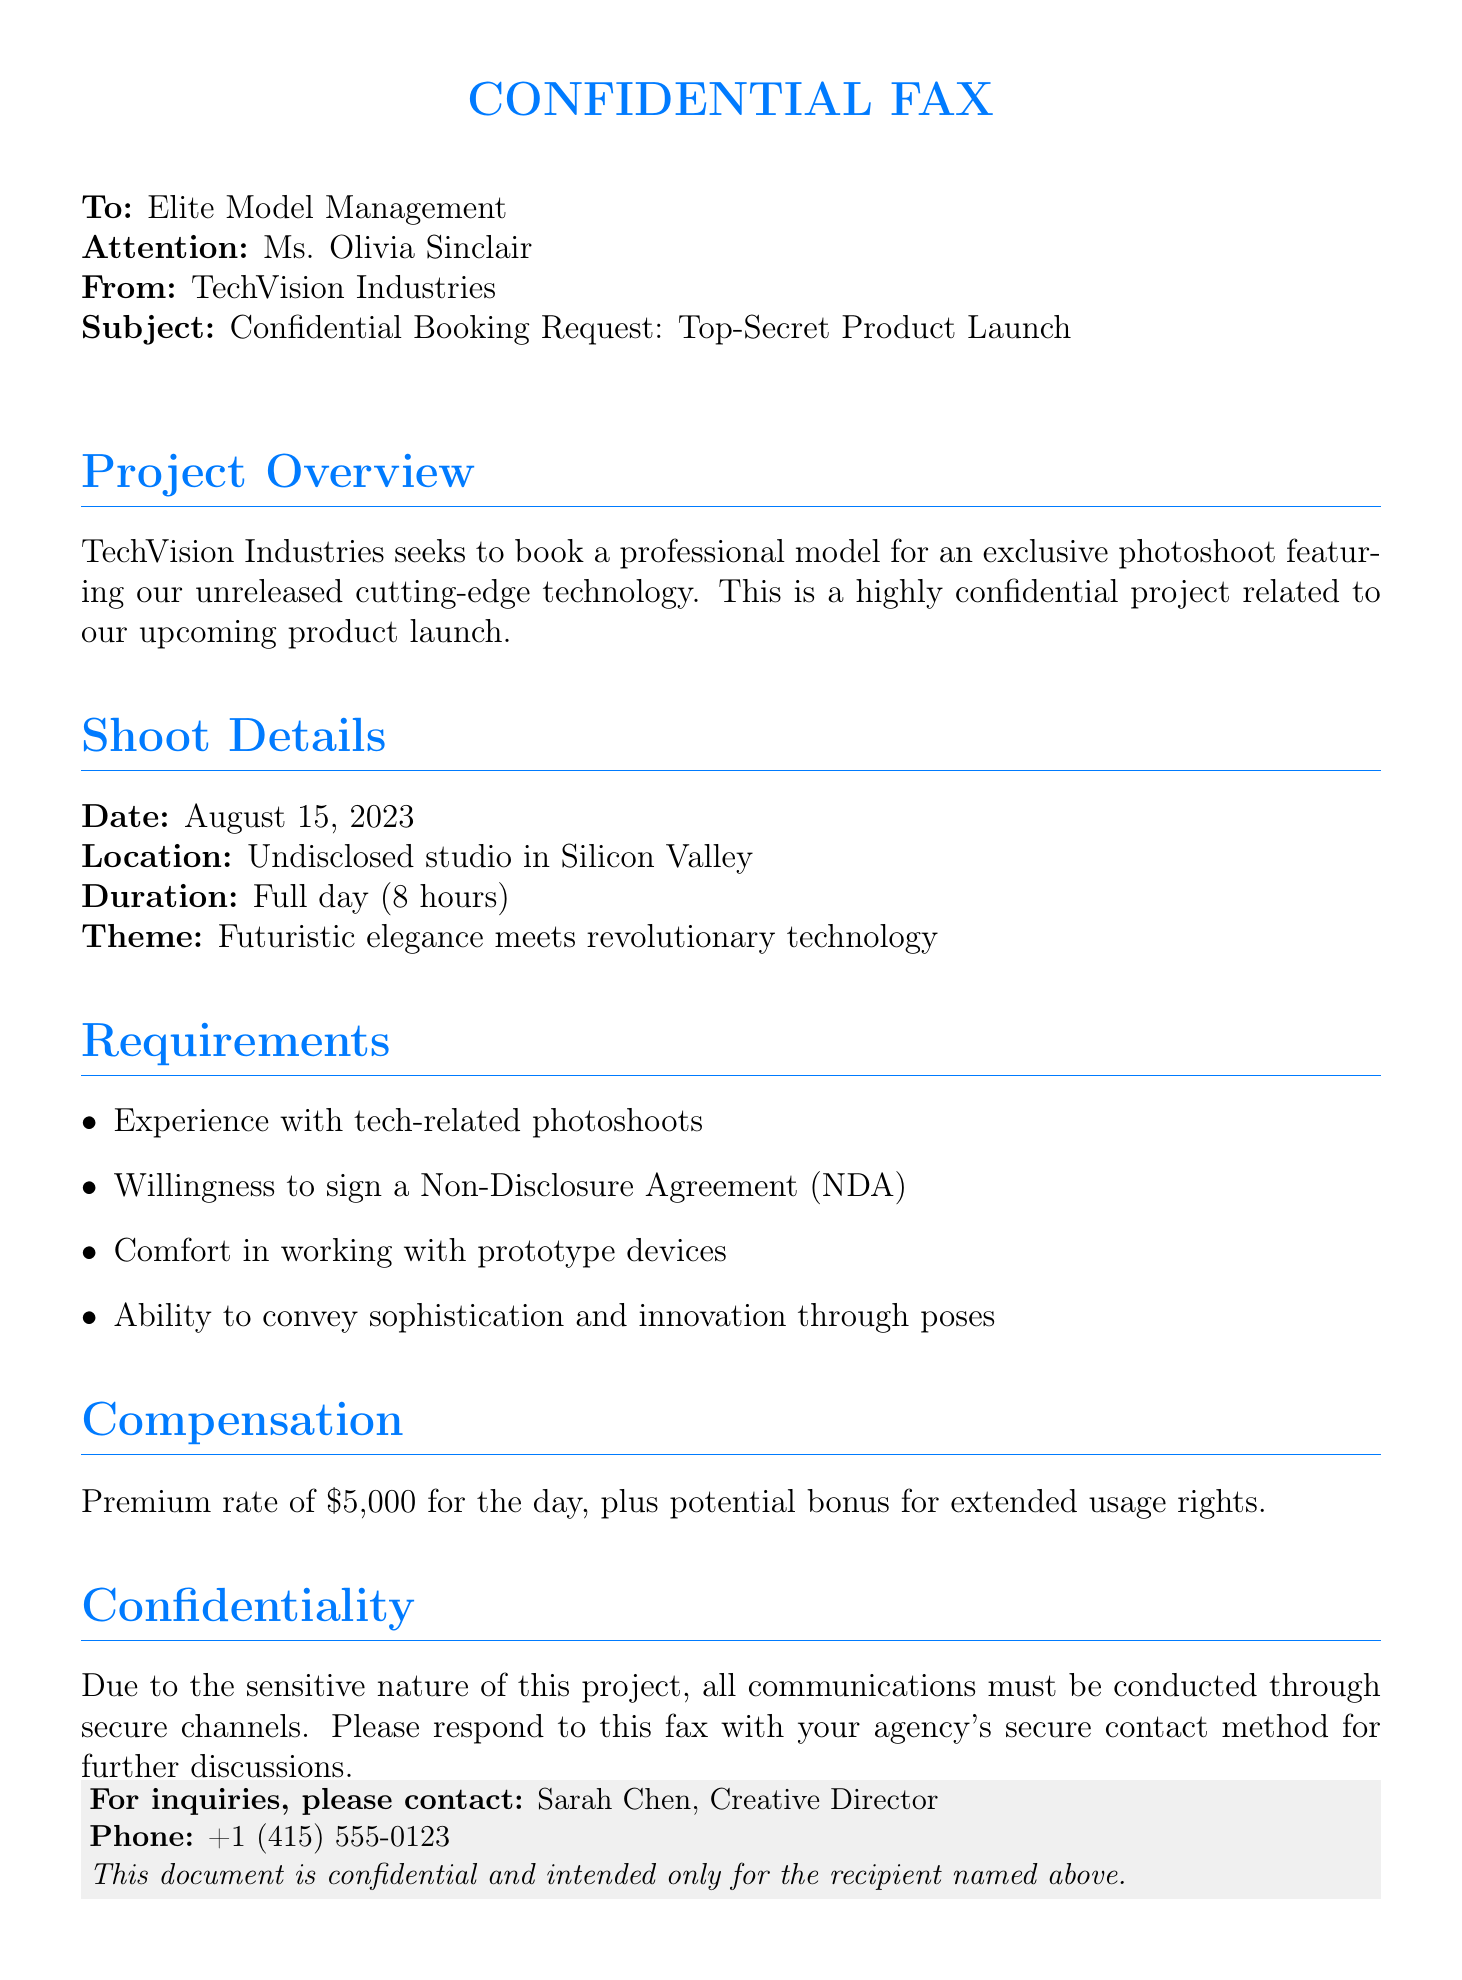What is the date of the photoshoot? The date mentioned in the document for the photoshoot is August 15, 2023.
Answer: August 15, 2023 Who is the contact person for inquiries? The contact person for inquiries, as stated in the document, is Sarah Chen.
Answer: Sarah Chen What is the theme of the photoshoot? The theme outlined in the document is "Futuristic elegance meets revolutionary technology."
Answer: Futuristic elegance meets revolutionary technology What is the compensation offered for the day? The premium rate mentioned in the document for the model's work is $5,000.
Answer: $5,000 What is required from the model regarding confidentiality? The model is required to sign a Non-Disclosure Agreement (NDA) according to the document.
Answer: Non-Disclosure Agreement (NDA) How long is the duration of the photoshoot? The duration of the photoshoot, as stated, is a full day (8 hours).
Answer: Full day (8 hours) What type of channel should communications be conducted through? The document specifies that all communications must be conducted through secure channels.
Answer: Secure channels What is the location of the photoshoot? The location for the photoshoot is an undisclosed studio in Silicon Valley, according to the document.
Answer: Undisclosed studio in Silicon Valley 